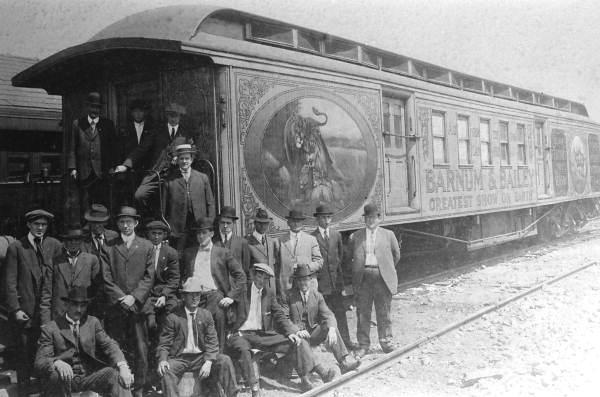Are they celebrating something?
Write a very short answer. No. Is any man photographed without his hat?
Write a very short answer. No. Is this a circus train?
Concise answer only. Yes. 